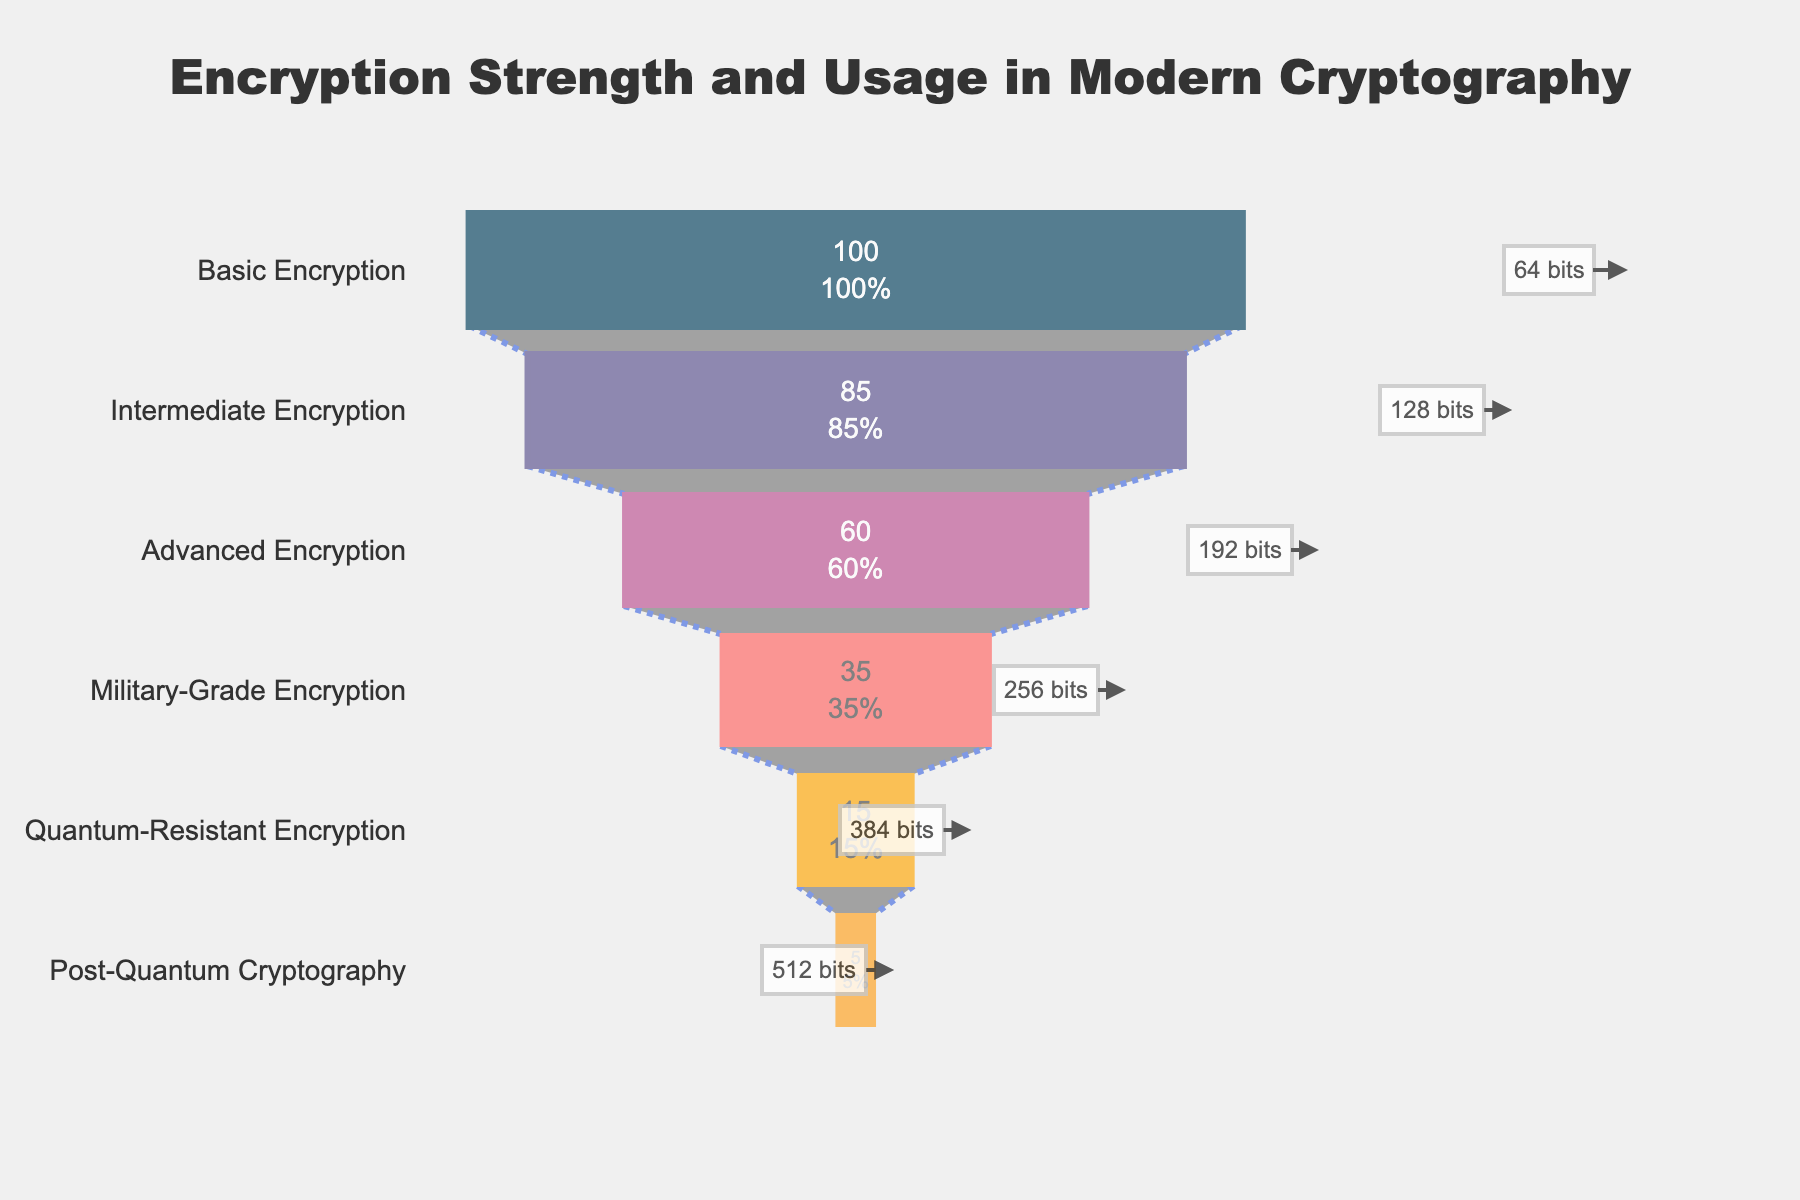what is the title of the figure? The title is usually located at the top center of the figure and is formatted to stand out. In this figure, the title contains the words "Encryption Strength and Usage in Modern Cryptography".
Answer: Encryption Strength and Usage in Modern Cryptography how many stages of encryption are depicted in the figure? By counting the number of different stages listed along the vertical axis of the funnel, we see there are six distinct stages shown in the chart.
Answer: Six which encryption stage has the highest usage percentage? The usage percentage values are displayed inside the funnel sections, and the first stage at the top (Basic Encryption) shows the highest usage percentage at 100%.
Answer: Basic Encryption what is the usage percentage for Military-Grade Encryption? The usage percentage for each stage is written inside the funnel section. For Military-Grade Encryption, the figure indicates a usage percentage of 35%.
Answer: 35% what are the two lowest usage percentages shown in the figure? By examining the usage percentage values inside the funnel sections, the two lowest values are for Post-Quantum Cryptography (5%) and Quantum-Resistant Encryption (15%).
Answer: Post-Quantum Cryptography and Quantum-Resistant Encryption what is the difference in encryption strength (bits) between Intermediate and Advanced Encryption stages? The encryption strength for Intermediate Encryption is 128 bits and for Advanced Encryption, it is 192 bits. The difference is calculated as 192 - 128.
Answer: 64 bits which encryption stage is closest to having half the usage percentage of the Basic Encryption stage? Basic Encryption has a usage percentage of 100%. Half of this is 50%. By comparing with the usage percentages of other stages, Advanced Encryption, with 60%, is the closest to 50%.
Answer: Advanced Encryption if 50,000 users are using Basic Encryption, how many of them would be using Intermediate Encryption? Basic Encryption has 100% usage, and Intermediate Encryption has 85% usage compared to Basic Encryption. Therefore, you would calculate 85% of 50,000 users by multiplying: 50,000 * 0.85.
Answer: 42,500 how do the usage percentages of Quantum-Resistant Encryption and Post-Quantum Cryptography compare in terms of difference? The figure shows that Quantum-Resistant Encryption has 15% usage, and Post-Quantum Cryptography has 5% usage. The difference is 15% - 5%.
Answer: 10% how does the funnel chart illustrate the decrease in usage percentages across encryption strength stages? The funnel chart visually narrows down from top to bottom, showing a decrease in width which represents usage percentages. Each subsequent stage has a visibly narrower section, indicating a drop in usage as encryption strength increases.
Answer: Narrowing stages signify decreasing usage 